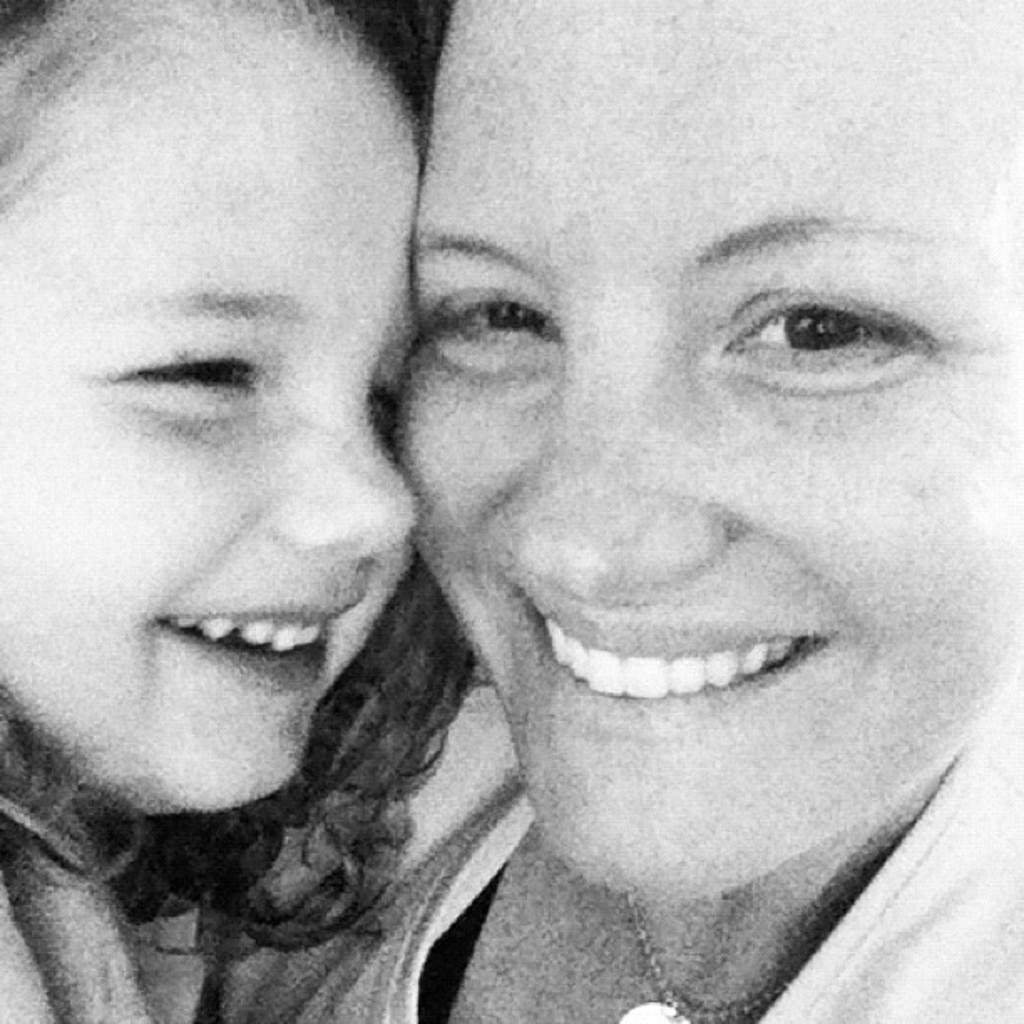Describe this image in one or two sentences. In this picture I can see a woman and a girl with smile on their faces. 